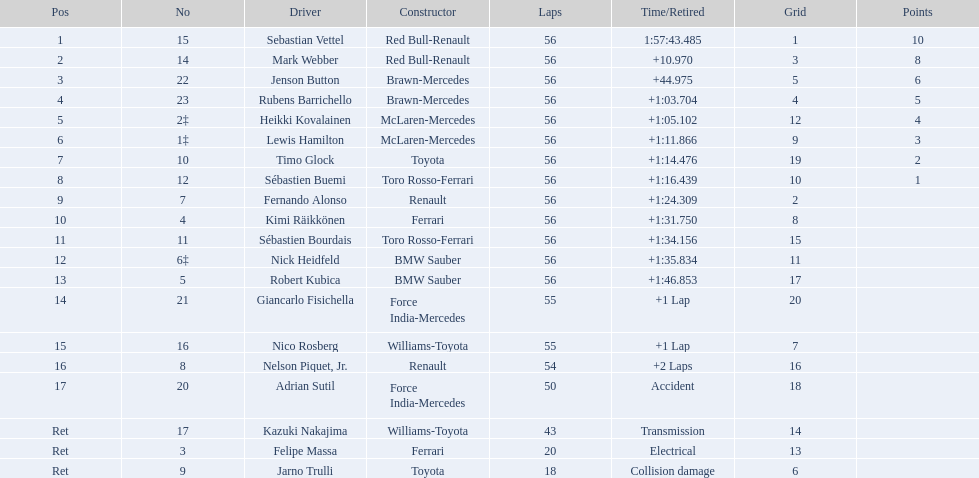Which driver ceased racing because of electrical troubles? Felipe Massa. Which driver stopped competing due to a crash? Adrian Sutil. Which driver ended their career because of collision-related damage? Jarno Trulli. 